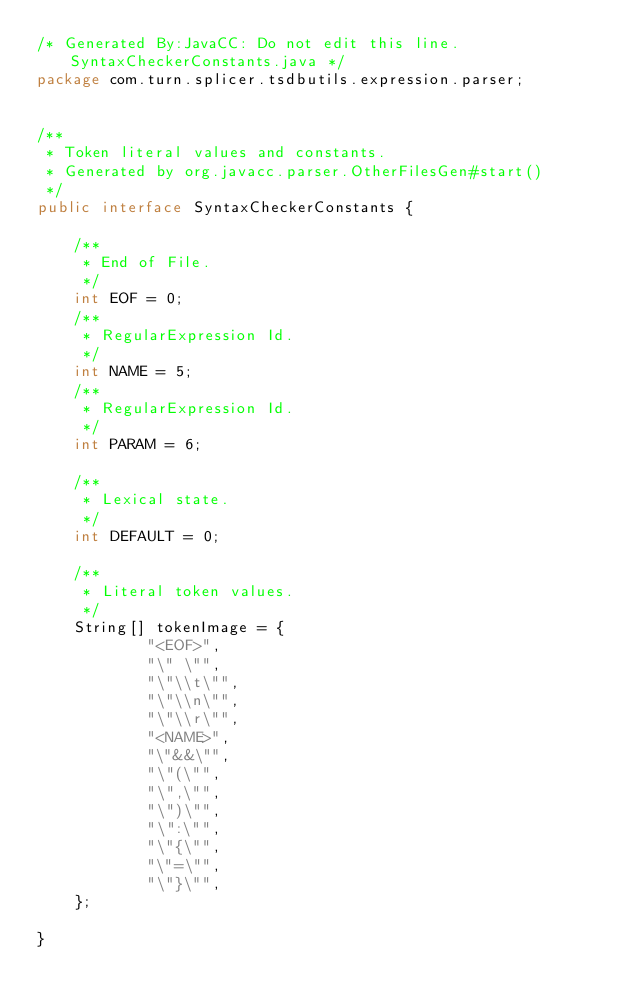<code> <loc_0><loc_0><loc_500><loc_500><_Java_>/* Generated By:JavaCC: Do not edit this line. SyntaxCheckerConstants.java */
package com.turn.splicer.tsdbutils.expression.parser;


/**
 * Token literal values and constants.
 * Generated by org.javacc.parser.OtherFilesGen#start()
 */
public interface SyntaxCheckerConstants {

	/**
	 * End of File.
	 */
	int EOF = 0;
	/**
	 * RegularExpression Id.
	 */
	int NAME = 5;
	/**
	 * RegularExpression Id.
	 */
	int PARAM = 6;

	/**
	 * Lexical state.
	 */
	int DEFAULT = 0;

	/**
	 * Literal token values.
	 */
	String[] tokenImage = {
			"<EOF>",
			"\" \"",
			"\"\\t\"",
			"\"\\n\"",
			"\"\\r\"",
			"<NAME>",
			"\"&&\"",
			"\"(\"",
			"\",\"",
			"\")\"",
			"\":\"",
			"\"{\"",
			"\"=\"",
			"\"}\"",
	};

}
</code> 